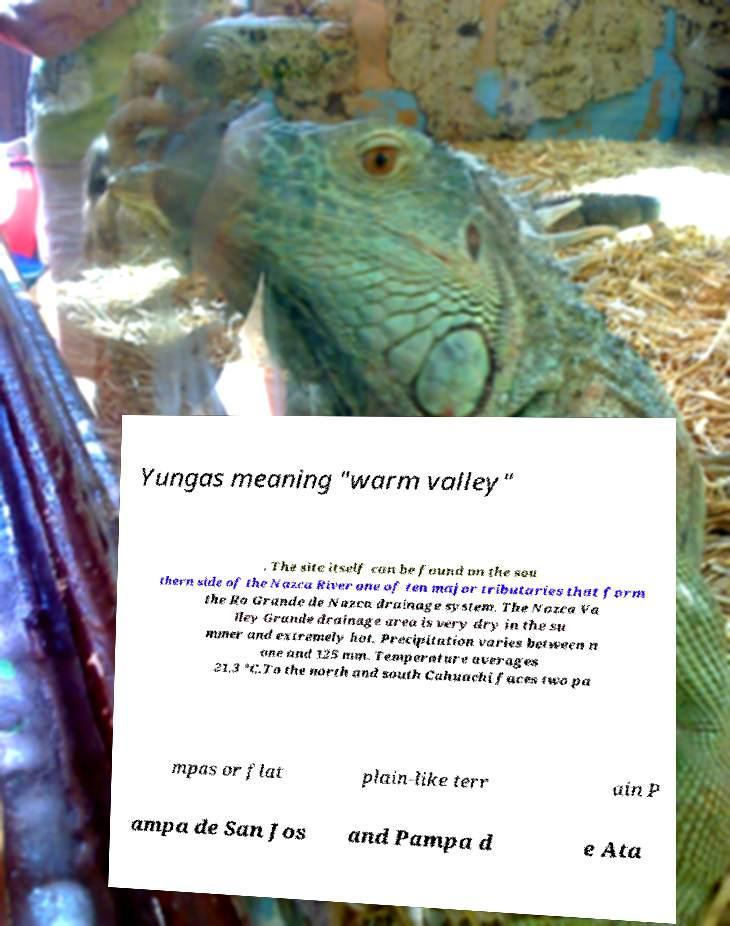Can you accurately transcribe the text from the provided image for me? Yungas meaning "warm valley" . The site itself can be found on the sou thern side of the Nazca River one of ten major tributaries that form the Ro Grande de Nazca drainage system. The Nazca Va lley Grande drainage area is very dry in the su mmer and extremely hot. Precipitation varies between n one and 125 mm. Temperature averages 21.3 °C.To the north and south Cahuachi faces two pa mpas or flat plain-like terr ain P ampa de San Jos and Pampa d e Ata 